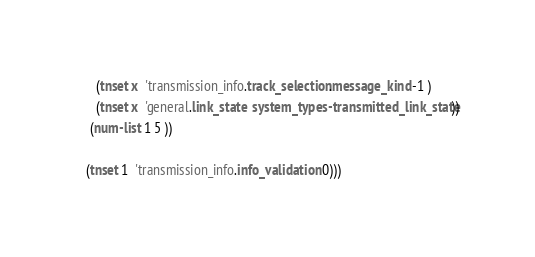Convert code to text. <code><loc_0><loc_0><loc_500><loc_500><_Scheme_>      (tnset x  'transmission_info.track_selection.message_kind -1 )
      (tnset x  'general.link_state  system_types-transmitted_link_state))
    (num-list 1 5 ))

   (tnset 1  'transmission_info.info_validation 0)))





</code> 